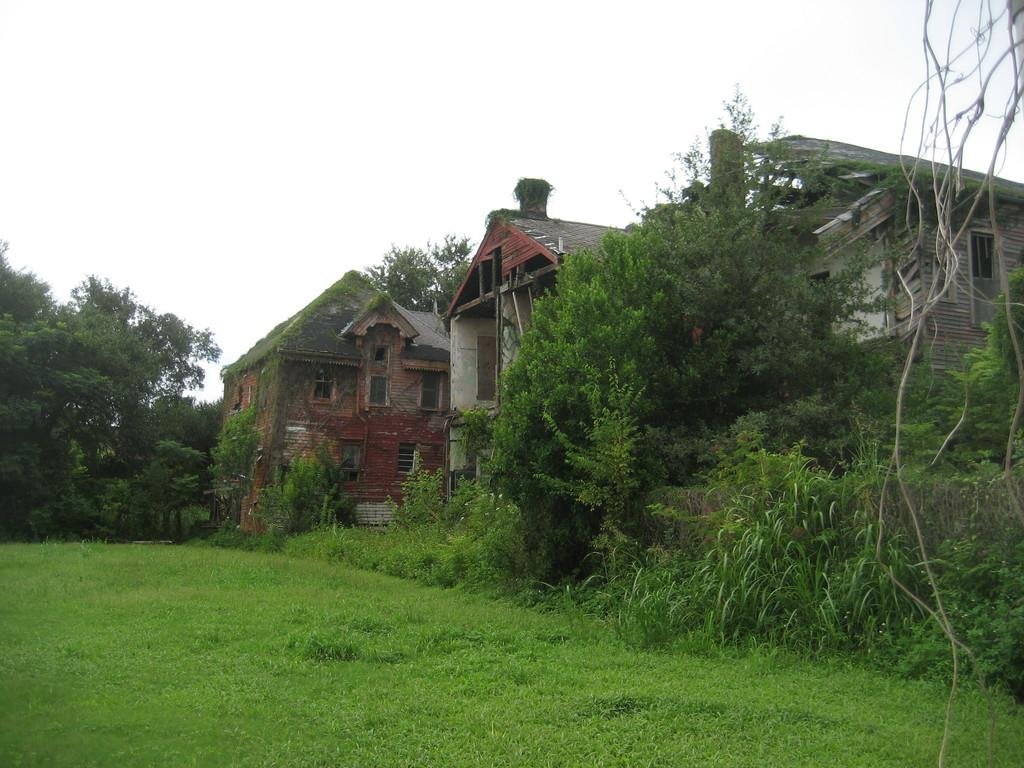What type of vegetation is present in the image? There is grass in the image. What other natural elements can be seen in the image? There are trees in the image. What man-made structures are visible in the image? There are buildings in the image. Can you see any donkeys grazing in the grass in the image? There is no donkey present in the image. How many ducks are swimming in the pond near the trees in the image? There is no pond or ducks present in the image. 